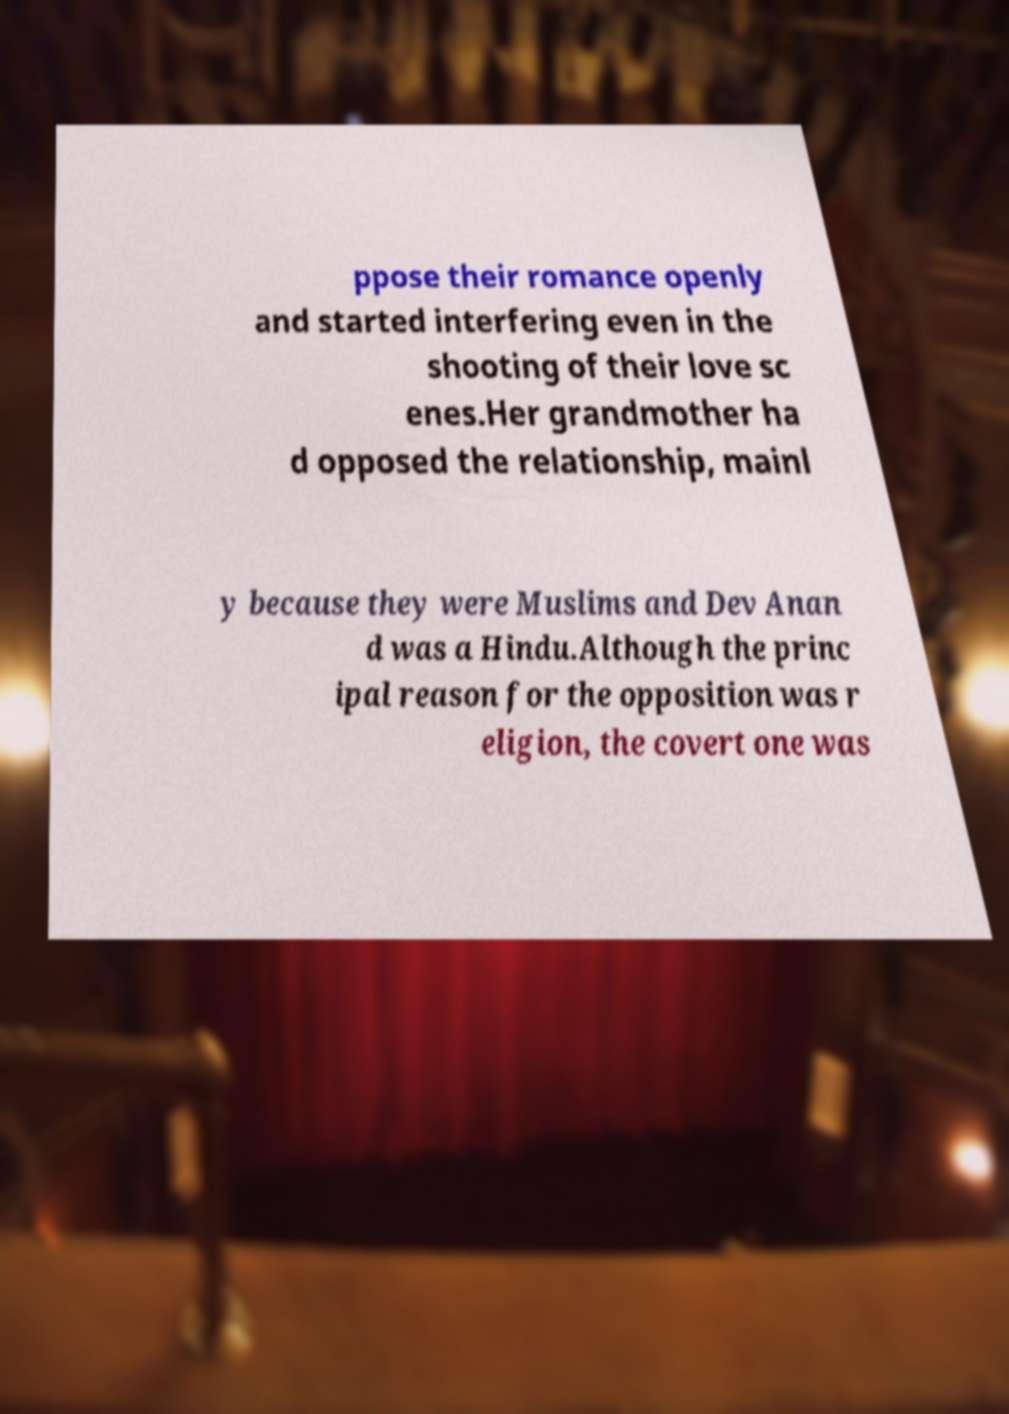Could you assist in decoding the text presented in this image and type it out clearly? ppose their romance openly and started interfering even in the shooting of their love sc enes.Her grandmother ha d opposed the relationship, mainl y because they were Muslims and Dev Anan d was a Hindu.Although the princ ipal reason for the opposition was r eligion, the covert one was 